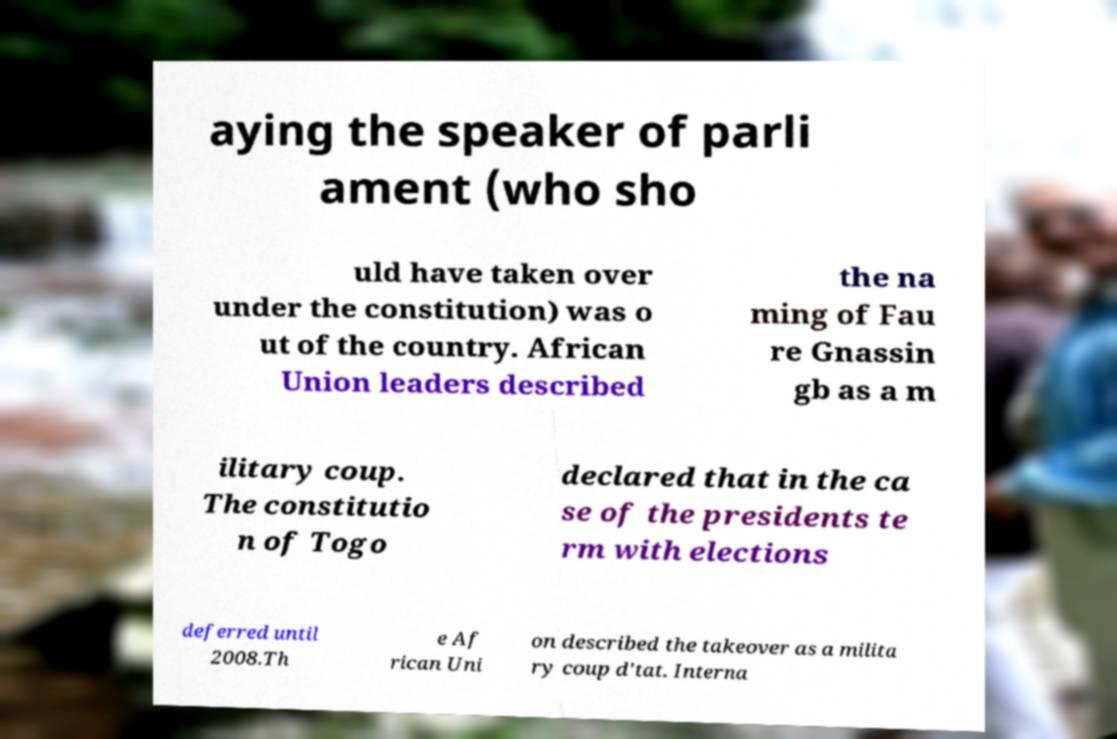For documentation purposes, I need the text within this image transcribed. Could you provide that? aying the speaker of parli ament (who sho uld have taken over under the constitution) was o ut of the country. African Union leaders described the na ming of Fau re Gnassin gb as a m ilitary coup. The constitutio n of Togo declared that in the ca se of the presidents te rm with elections deferred until 2008.Th e Af rican Uni on described the takeover as a milita ry coup d'tat. Interna 